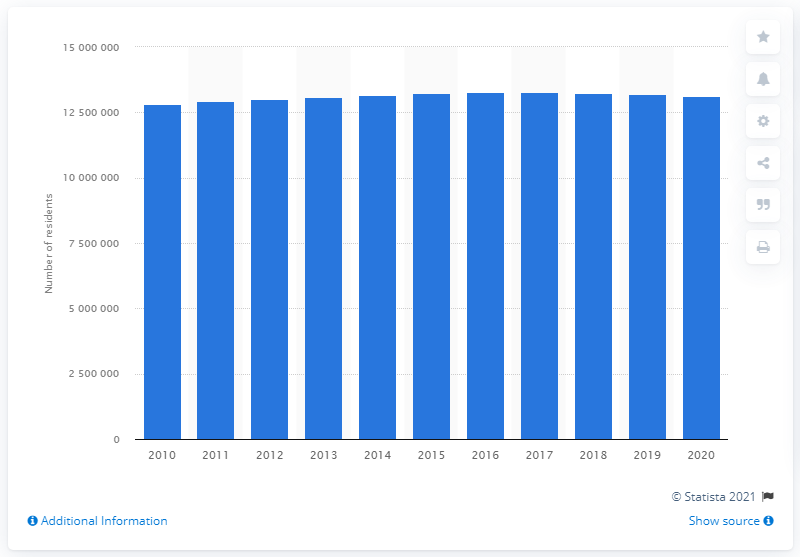Highlight a few significant elements in this photo. The population of the Los Angeles-Long Beach-Anaheim metropolitan area in the previous year was 1,309,245. In the year 2020, the population of the Los Angeles-Long Beach-Anaheim metropolitan area was 13,010,104. 